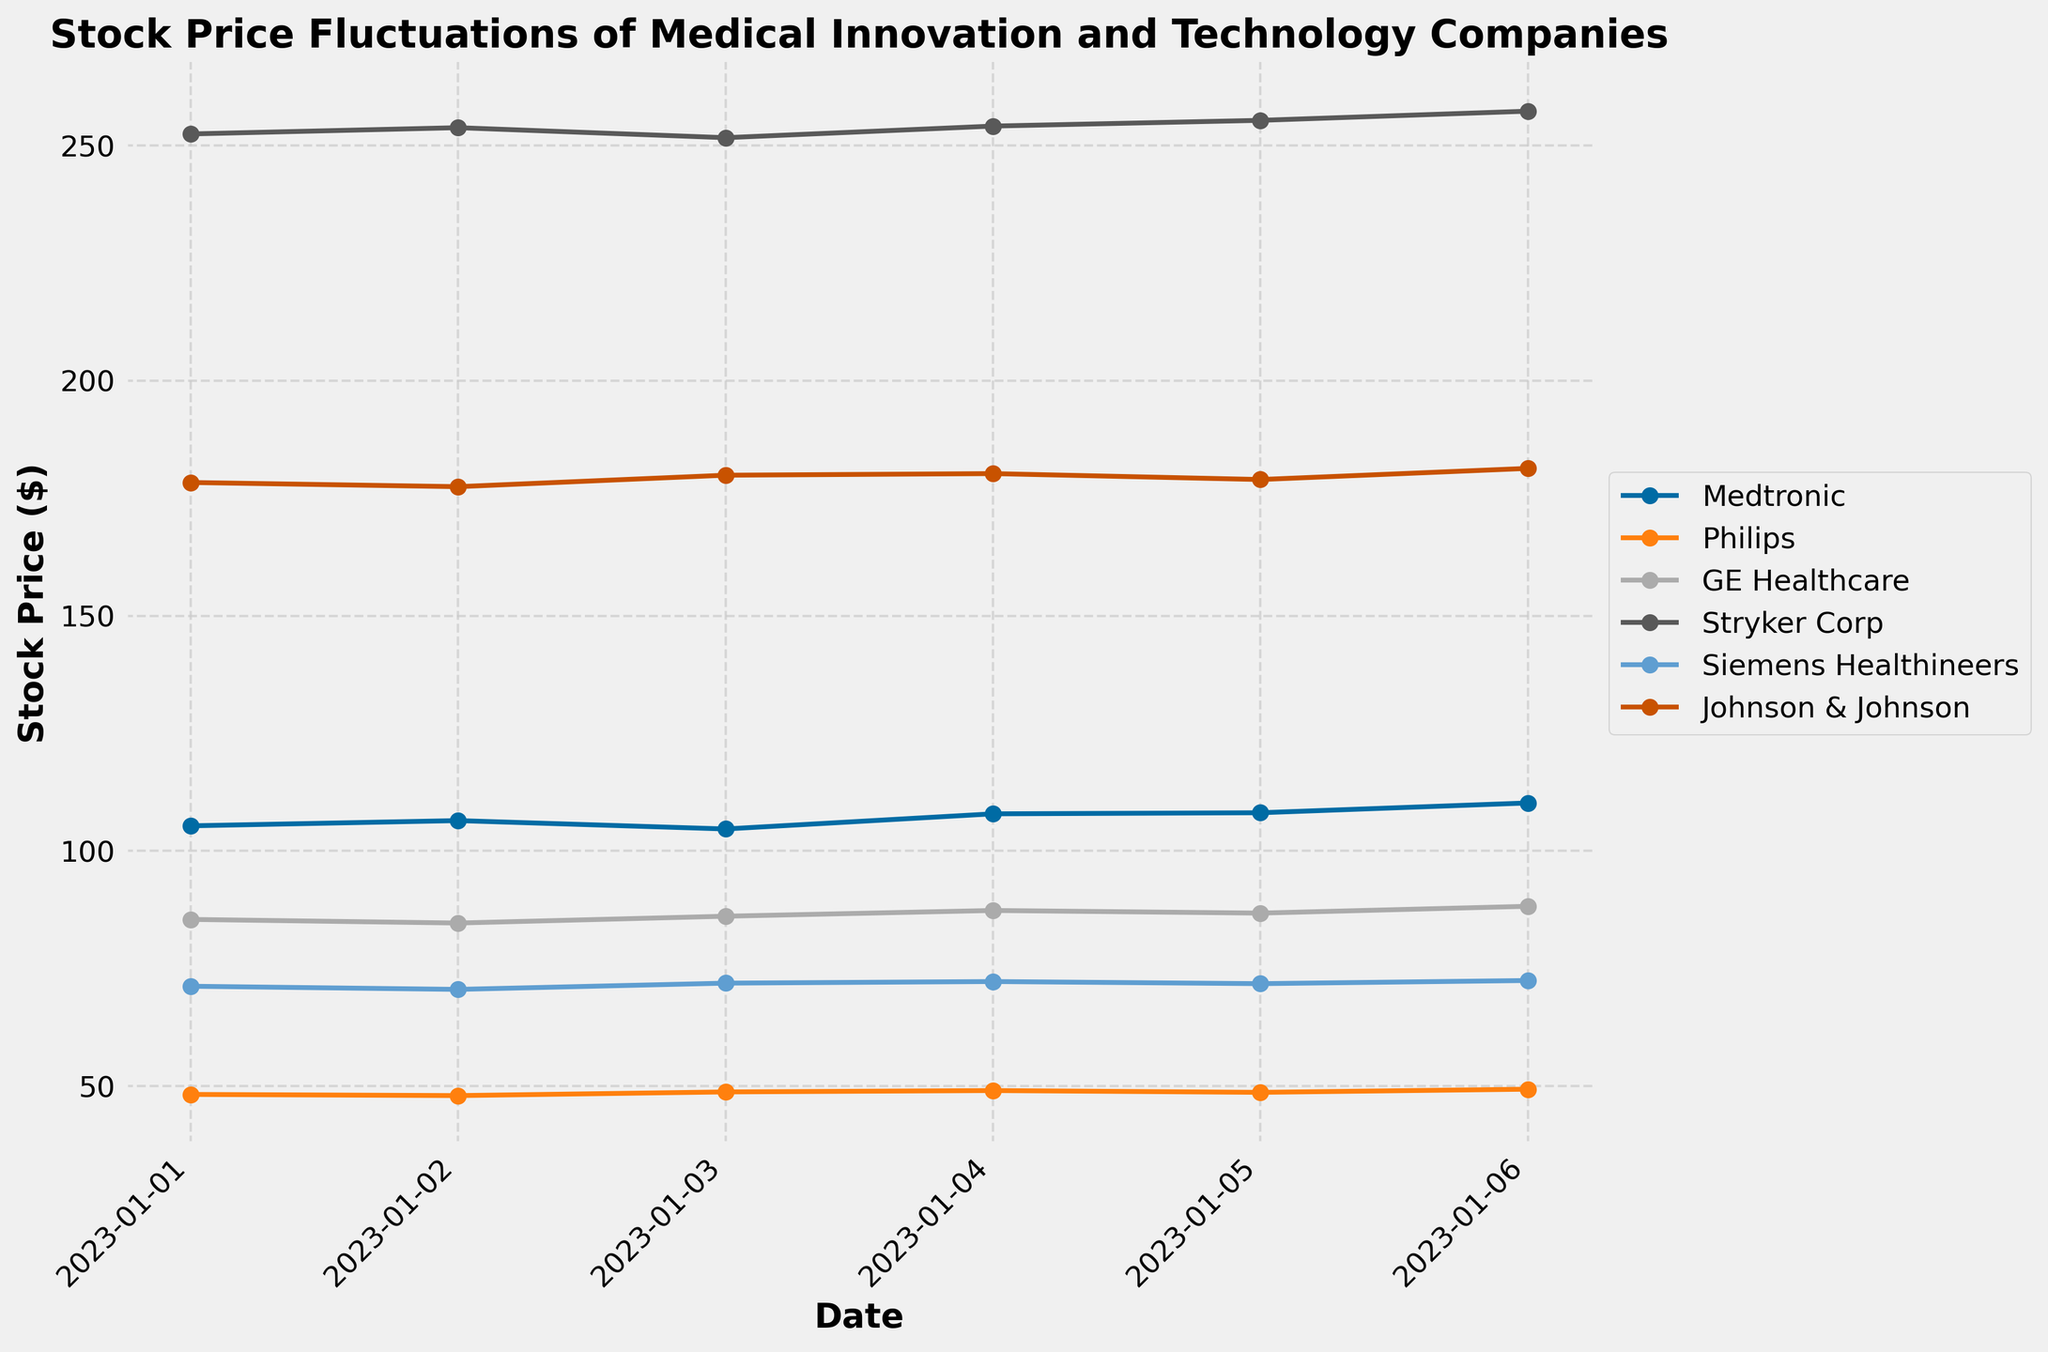What is the title of the plot? The title is typically found at the top of the figure and provides insight into what is being displayed. Look at the top of the plot to find this information.
Answer: Stock Price Fluctuations of Medical Innovation and Technology Companies Which company had the highest stock price on January 6, 2023? To answer this, find the data points for January 6 for each company and compare their values to see which one is the highest.
Answer: Stryker Corp What is the stock price trend for Medtronic from January 1 to January 6, 2023? Observe the line representing Medtronic in the plot: check if it is generally increasing, decreasing, or fluctuating over time.
Answer: Increasing What is the average stock price of Philips over the period shown in the plot? Sum all the Philips stock prices over the given dates and divide by the total number of days (6). (48.23 + 47.98 + 48.76 + 49.05 + 48.67 + 49.34) ÷ 6
Answer: 48.67 Which date shows the lowest stock price for GE Healthcare? Look for the data point representing the lowest stock price for GE Healthcare on the plot, and note the corresponding date.
Answer: January 2, 2023 Between Siemens Healthineers and Johnson & Johnson, which company showed a higher stock price on January 3, 2023? Compare the stock prices depicted for Siemens Healthineers and Johnson & Johnson on January 3 by examining the respective points on the plot.
Answer: Johnson & Johnson What is the percentage increase in Stryker Corp's stock price from January 1 to January 6, 2023? Calculate the percentage increase from the initial price to the final price ([(final price - initial price) / initial price] * 100). [(257.29 - 252.45) / 252.45] * 100
Answer: 1.91% How did Philips' stock prices compare from January 1 to January 6, 2023? Analyze the plot to see if Philips’ stock prices increased, decreased, or remained relatively stable over the given period.
Answer: Increased On which days did Medtronic reach its peak stock price within the displayed dates? Find the highest stock price point for Medtronic and determine the corresponding dates from the plot's x-axis.
Answer: January 6, 2023 Which company's stock price fluctuated the most during the period shown in the plot? Examine the spread between the highest and lowest points for each company and identify the largest range.
Answer: Medtronic 